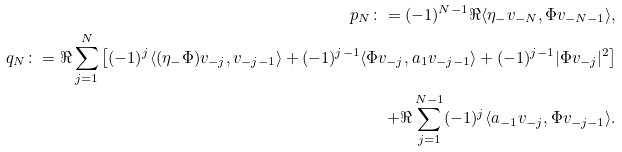<formula> <loc_0><loc_0><loc_500><loc_500>p _ { N } \colon = ( - 1 ) ^ { N - 1 } \Re \langle \eta _ { - } v _ { - N } , \Phi v _ { - N - 1 } \rangle , \\ q _ { N } \colon = \Re \sum _ { j = 1 } ^ { N } \left [ ( - 1 ) ^ { j } \langle ( \eta _ { - } \Phi ) v _ { - j } , v _ { - j - 1 } \rangle + ( - 1 ) ^ { j - 1 } \langle \Phi v _ { - j } , a _ { 1 } v _ { - j - 1 } \rangle + ( - 1 ) ^ { j - 1 } | \Phi v _ { - j } | ^ { 2 } \right ] \\ + \Re \sum _ { j = 1 } ^ { N - 1 } ( - 1 ) ^ { j } \langle a _ { - 1 } v _ { - j } , \Phi v _ { - j - 1 } \rangle .</formula> 